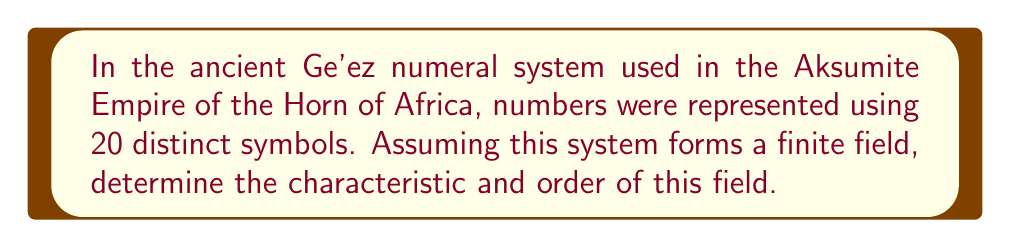Give your solution to this math problem. To solve this problem, we need to follow these steps:

1) In a finite field, the number of elements must be a prime power, $p^n$, where $p$ is a prime number and $n$ is a positive integer.

2) Given that there are 20 distinct symbols in the Ge'ez numeral system, we need to find $p$ and $n$ such that $p^n = 20$.

3) Factoring 20:
   $20 = 2^2 \times 5$

4) Since 20 is not a prime power, it cannot form a field with 20 elements.

5) However, we can consider the smallest prime power greater than 20, which would be $5^2 = 25$.

6) In this case, the characteristic of the field would be 5 (the prime base), and the order of the field would be 25.

7) This means that the Ge'ez numeral system, when extended to include 5 additional symbols, could theoretically form a finite field.

8) The operations in this field would be performed modulo 5, and each element would have an additive and multiplicative inverse (except 0 for multiplication).
Answer: Characteristic: 5, Order: 25 